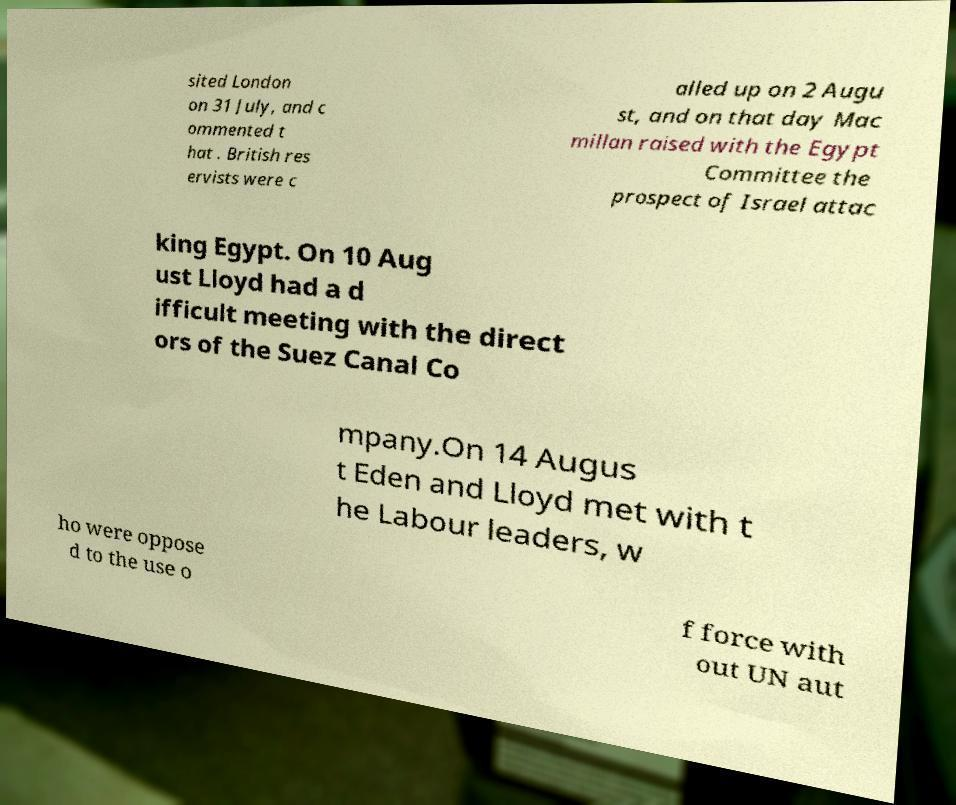Please read and relay the text visible in this image. What does it say? sited London on 31 July, and c ommented t hat . British res ervists were c alled up on 2 Augu st, and on that day Mac millan raised with the Egypt Committee the prospect of Israel attac king Egypt. On 10 Aug ust Lloyd had a d ifficult meeting with the direct ors of the Suez Canal Co mpany.On 14 Augus t Eden and Lloyd met with t he Labour leaders, w ho were oppose d to the use o f force with out UN aut 